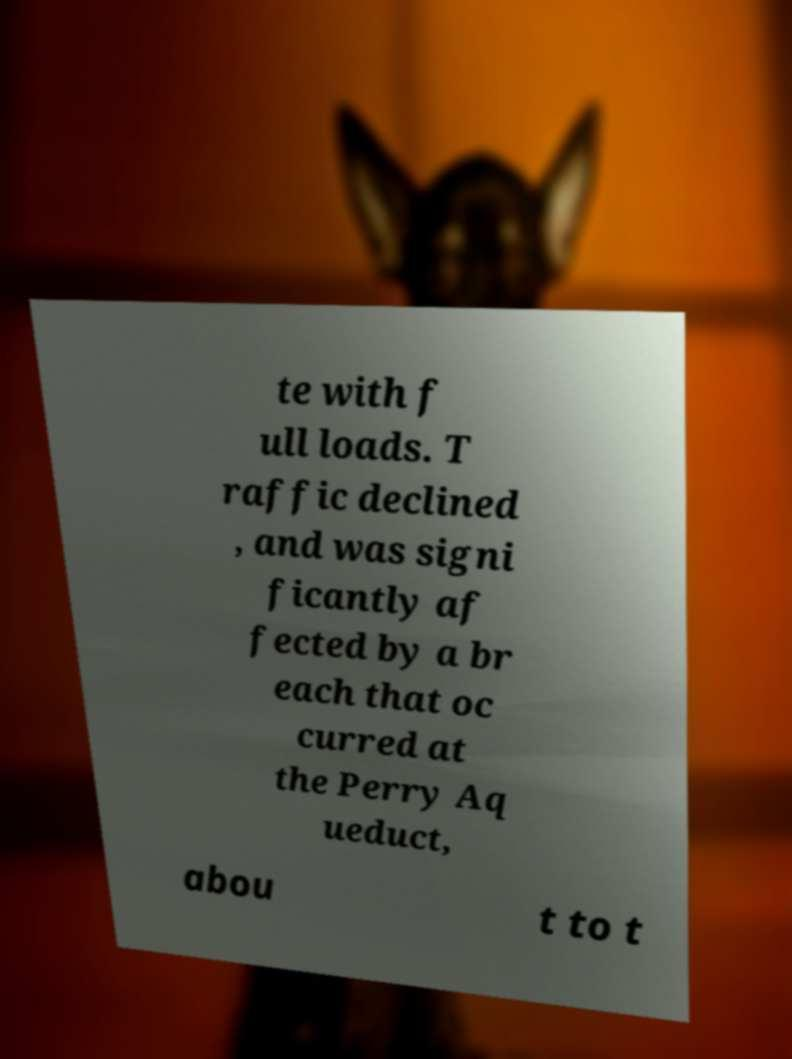Can you read and provide the text displayed in the image?This photo seems to have some interesting text. Can you extract and type it out for me? te with f ull loads. T raffic declined , and was signi ficantly af fected by a br each that oc curred at the Perry Aq ueduct, abou t to t 